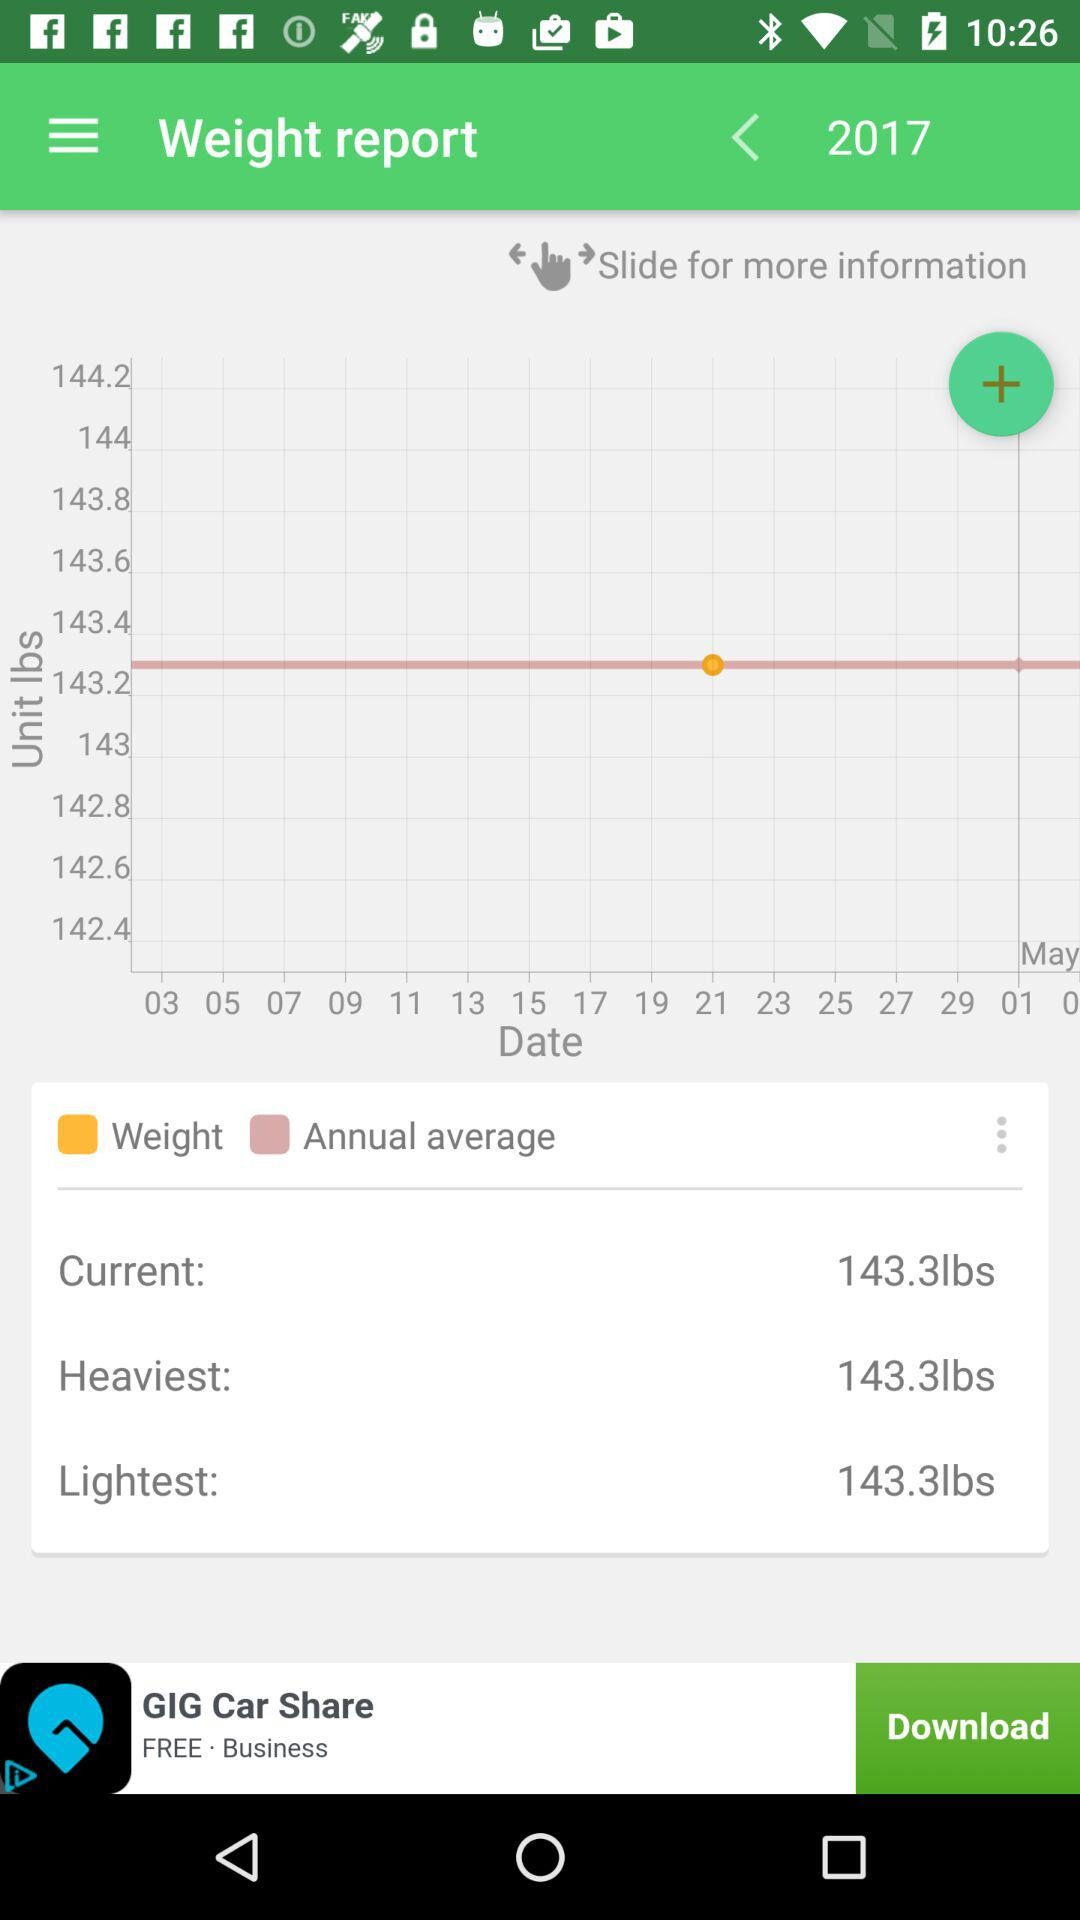What is the current weight in the report? The current weight is 143.3 lbs. 